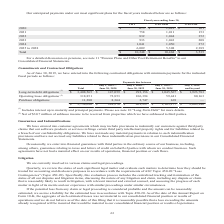According to Opentext Corporation's financial document, What does the table show? contractual obligations with minimum payments for the indicated fiscal periods. The document states: "June 30, 2019, we have entered into the following contractual obligations with minimum payments for the indicated fiscal periods as follows:..." Also, For Operating lease obligations, what is the Net of value for sublease income to be received from properties which have been subleased to third parties? According to the financial document, $30.7 million. The relevant text states: "(2) Net of $30.7 million of sublease income to be received from properties which we have subleased to third parties...." Also, What is the Total Commitments and Contractual Obligations? According to the financial document, 3,738,696 (in thousands). The relevant text states: "3 Purchase obligations 11,280 8,364 2,747 169 — $ 3,738,696 $ 228,276 $ 401,297 $ 1,105,177 $ 2,003,946..." Also, can you calculate: What is the average annual fiscal year Long-term debt obligations for fiscal year 2020 to 2024? To answer this question, I need to perform calculations using the financial data. The calculation is: (147,059+292,156+1,045,567)/5, which equals 296956.4 (in thousands). This is based on the information: "yond Long-term debt obligations (1) $ 3,408,565 $ 147,059 $ 292,156 $ 1,045,567 $ 1,923,783 Operating lease obligations (2) 318,851 72,853 106,394 59,441 80, term debt obligations (1) $ 3,408,565 $ 14..." The key data points involved are: 1,045,567, 147,059, 292,156. Also, can you calculate: What is the Total obligations of July 1, 2024 and beyond expressed as a percentage of Total obligations? Based on the calculation: 2,003,946/3,738,696, the result is 53.6 (percentage). This is based on the information: "9 — $ 3,738,696 $ 228,276 $ 401,297 $ 1,105,177 $ 2,003,946 3 Purchase obligations 11,280 8,364 2,747 169 — $ 3,738,696 $ 228,276 $ 401,297 $ 1,105,177 $ 2,003,946..." The key data points involved are: 2,003,946, 3,738,696. Also, can you calculate: For July 1, 2024 and beyond, what is Long-term debt obligations expressed as a percentage of Total obligations? Based on the calculation: 1,923,783/2,003,946, the result is 96 (percentage). This is based on the information: "(1) $ 3,408,565 $ 147,059 $ 292,156 $ 1,045,567 $ 1,923,783 Operating lease obligations (2) 318,851 72,853 106,394 59,441 80,163 Purchase obligations 11,280 8, 9 — $ 3,738,696 $ 228,276 $ 401,297 $ 1,..." The key data points involved are: 1,923,783, 2,003,946. 